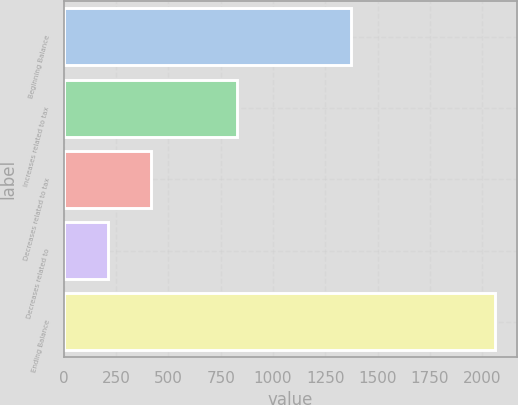Convert chart. <chart><loc_0><loc_0><loc_500><loc_500><bar_chart><fcel>Beginning Balance<fcel>Increases related to tax<fcel>Decreases related to tax<fcel>Decreases related to<fcel>Ending Balance<nl><fcel>1375<fcel>826.6<fcel>414.8<fcel>208.9<fcel>2062<nl></chart> 